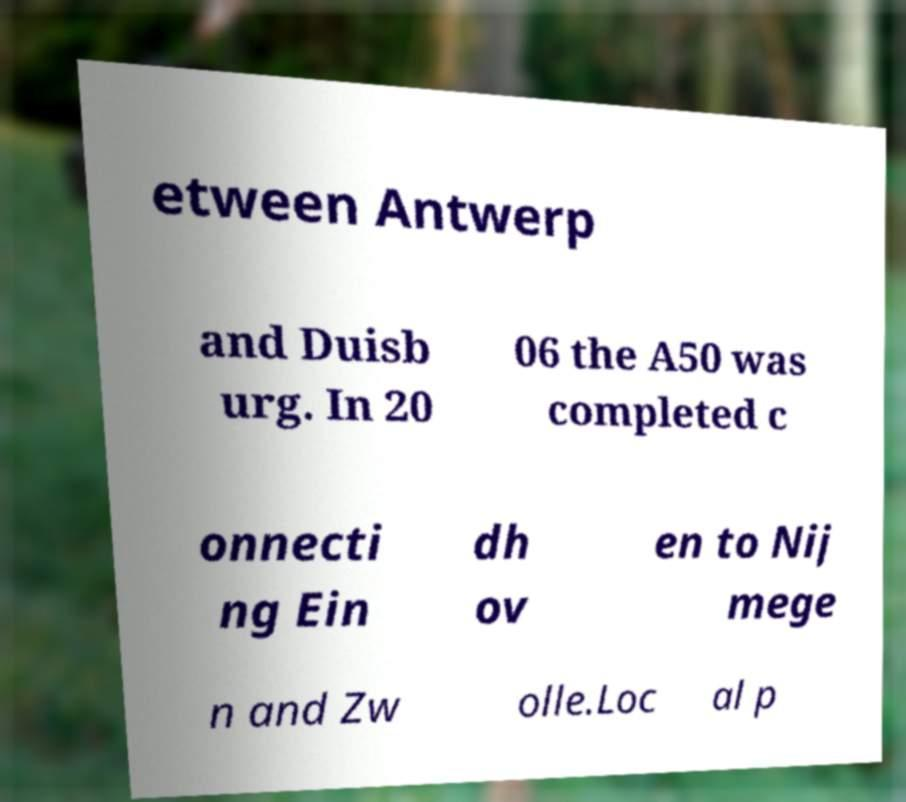Could you assist in decoding the text presented in this image and type it out clearly? etween Antwerp and Duisb urg. In 20 06 the A50 was completed c onnecti ng Ein dh ov en to Nij mege n and Zw olle.Loc al p 